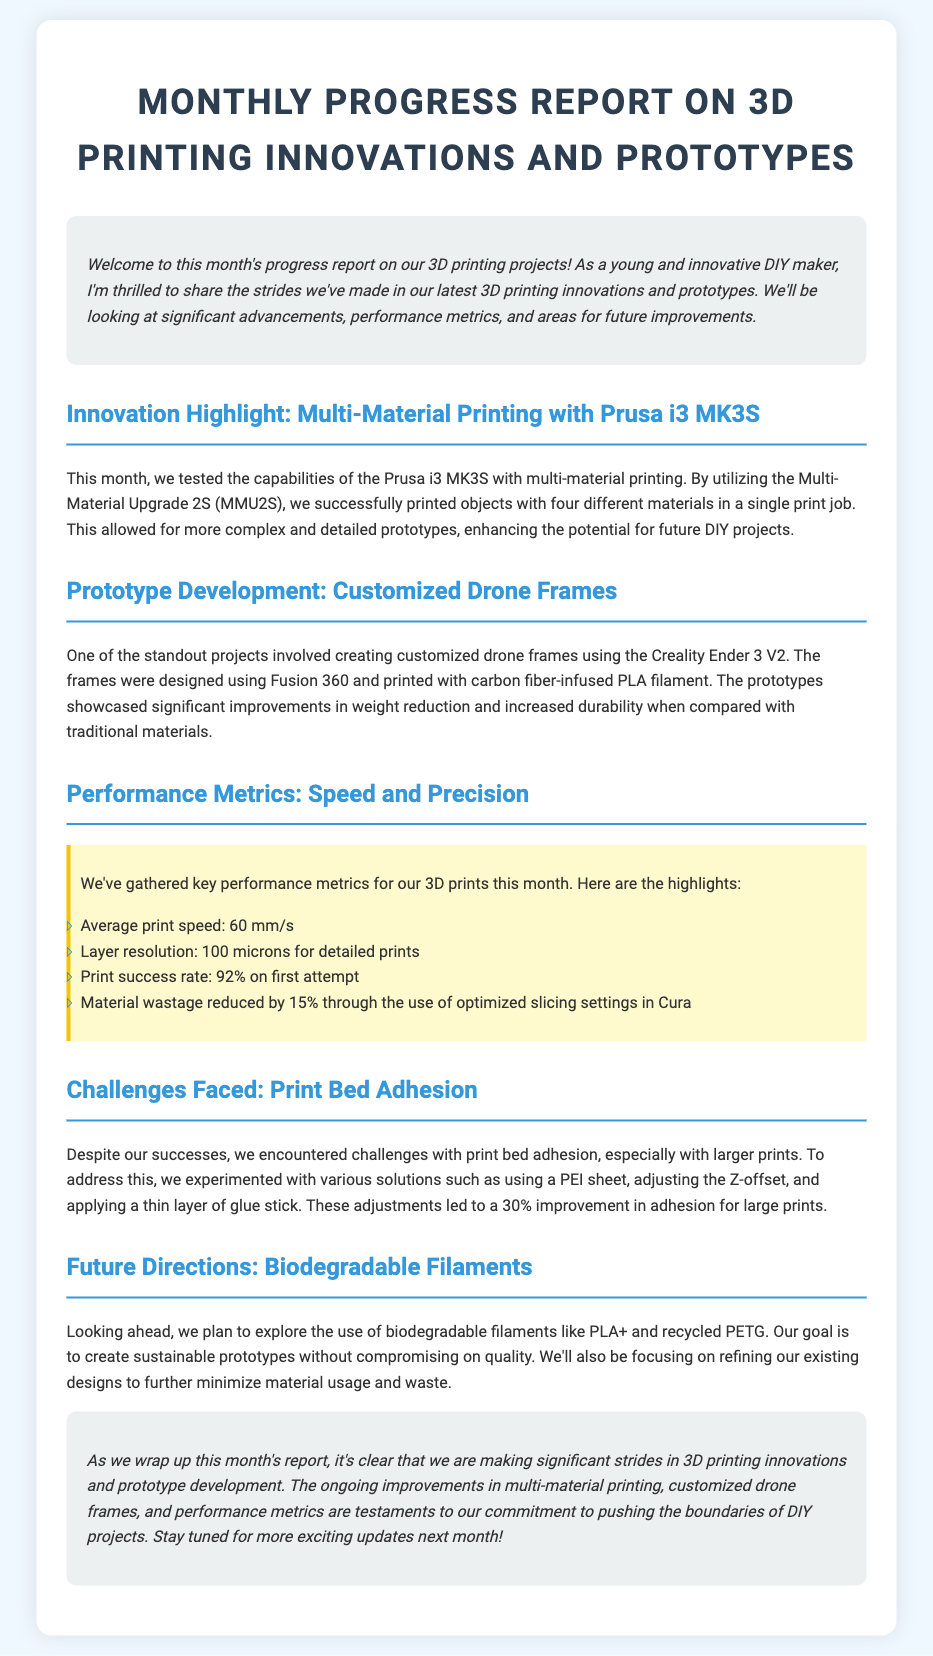What is the average print speed? The average print speed is listed as 60 mm/s in the performance metrics section of the document.
Answer: 60 mm/s What material was used for the customized drone frames? The document states that the drone frames were printed with carbon fiber-infused PLA filament.
Answer: Carbon fiber-infused PLA What is the print success rate on the first attempt? The document mentions a print success rate of 92% on the first attempt in the performance metrics section.
Answer: 92% What challenge was faced regarding larger prints? The document discusses challenges with print bed adhesion specifically for larger prints.
Answer: Print bed adhesion What solution led to a 30% improvement in adhesion? The document states that adjustments, including using a PEI sheet, contributed to a 30% improvement in adhesion for large prints.
Answer: Adjustments (PEI sheet, Z-offset, glue stick) What biodegradable filaments are planned for future exploration? The document indicates plans to explore biodegradable filaments like PLA+ and recycled PETG.
Answer: PLA+ and recycled PETG Which printer was used for multi-material printing? The Prusa i3 MK3S was used for multi-material printing as highlighted in the innovations section.
Answer: Prusa i3 MK3S What was the layer resolution for detailed prints? The layer resolution for detailed prints is mentioned as 100 microns in the performance metrics.
Answer: 100 microns 